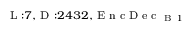Convert formula to latex. <formula><loc_0><loc_0><loc_500><loc_500>_ { L \colon 7 , D \colon 2 4 3 2 , E n c D e c _ { B 1 } }</formula> 